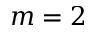<formula> <loc_0><loc_0><loc_500><loc_500>m = 2</formula> 